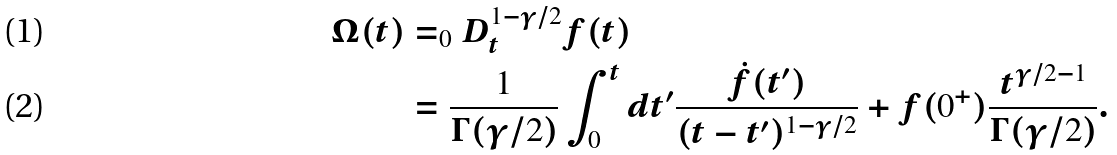<formula> <loc_0><loc_0><loc_500><loc_500>\Omega ( t ) & = _ { 0 } D _ { t } ^ { 1 - \gamma / 2 } f ( t ) \\ & = \frac { 1 } { \Gamma ( \gamma / 2 ) } \int _ { 0 } ^ { t } d t ^ { \prime } \frac { \dot { f } ( t ^ { \prime } ) } { ( t - t ^ { \prime } ) ^ { 1 - \gamma / 2 } } + f ( 0 ^ { + } ) \frac { t ^ { \gamma / 2 - 1 } } { \Gamma ( \gamma / 2 ) } .</formula> 